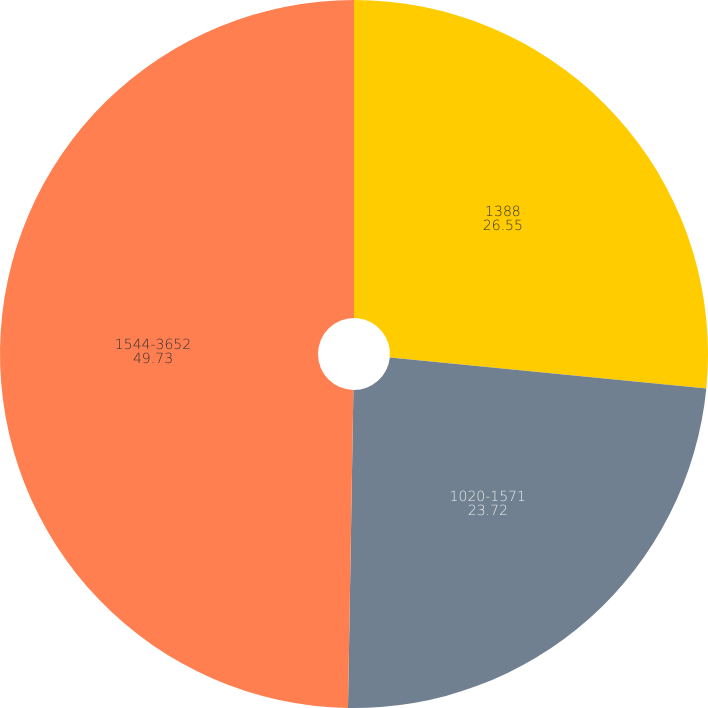<chart> <loc_0><loc_0><loc_500><loc_500><pie_chart><fcel>1388<fcel>1020-1571<fcel>1544-3652<nl><fcel>26.55%<fcel>23.72%<fcel>49.73%<nl></chart> 